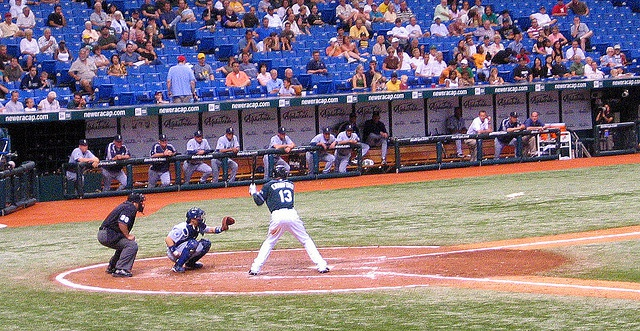Describe the objects in this image and their specific colors. I can see people in purple, black, navy, lavender, and blue tones, chair in purple, blue, and darkblue tones, people in purple, white, navy, darkgray, and violet tones, people in purple, black, navy, lavender, and gray tones, and people in purple, black, gray, and navy tones in this image. 